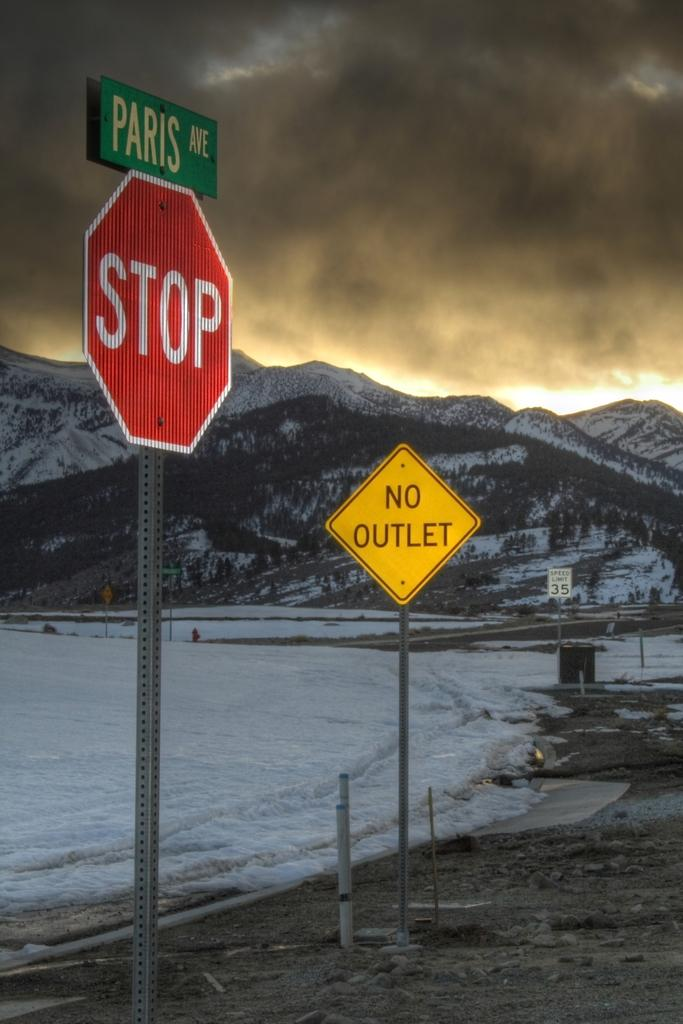<image>
Share a concise interpretation of the image provided. A mountain with a stop sign and No Outlet sign in the foreground 